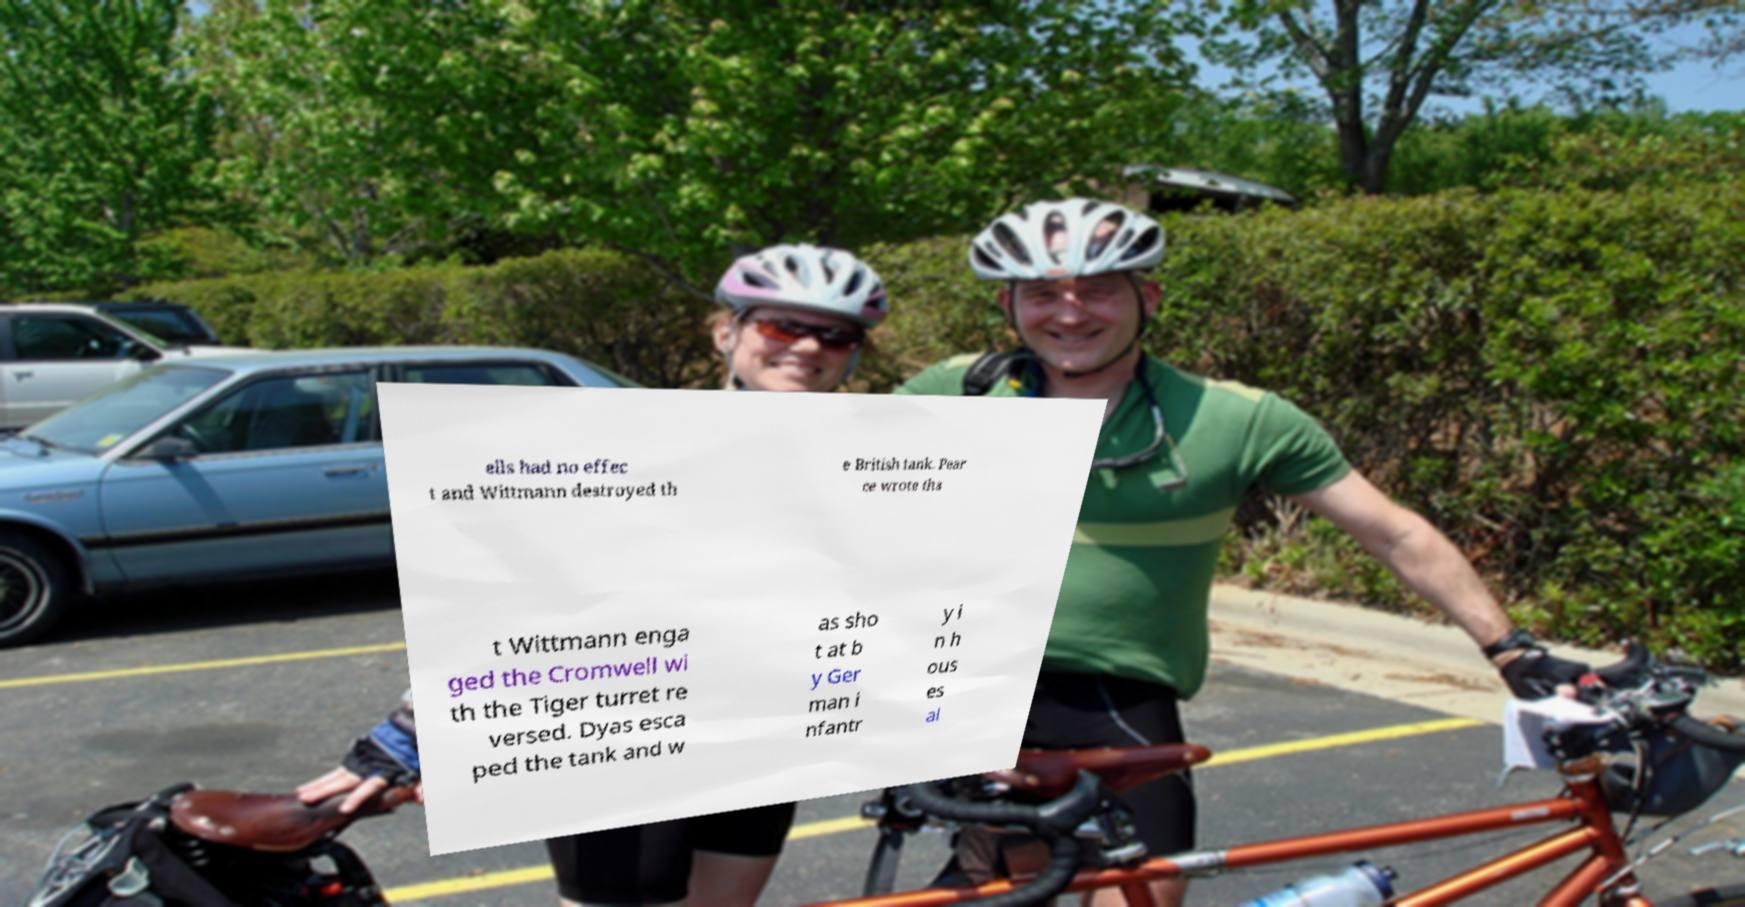What messages or text are displayed in this image? I need them in a readable, typed format. ells had no effec t and Wittmann destroyed th e British tank. Pear ce wrote tha t Wittmann enga ged the Cromwell wi th the Tiger turret re versed. Dyas esca ped the tank and w as sho t at b y Ger man i nfantr y i n h ous es al 